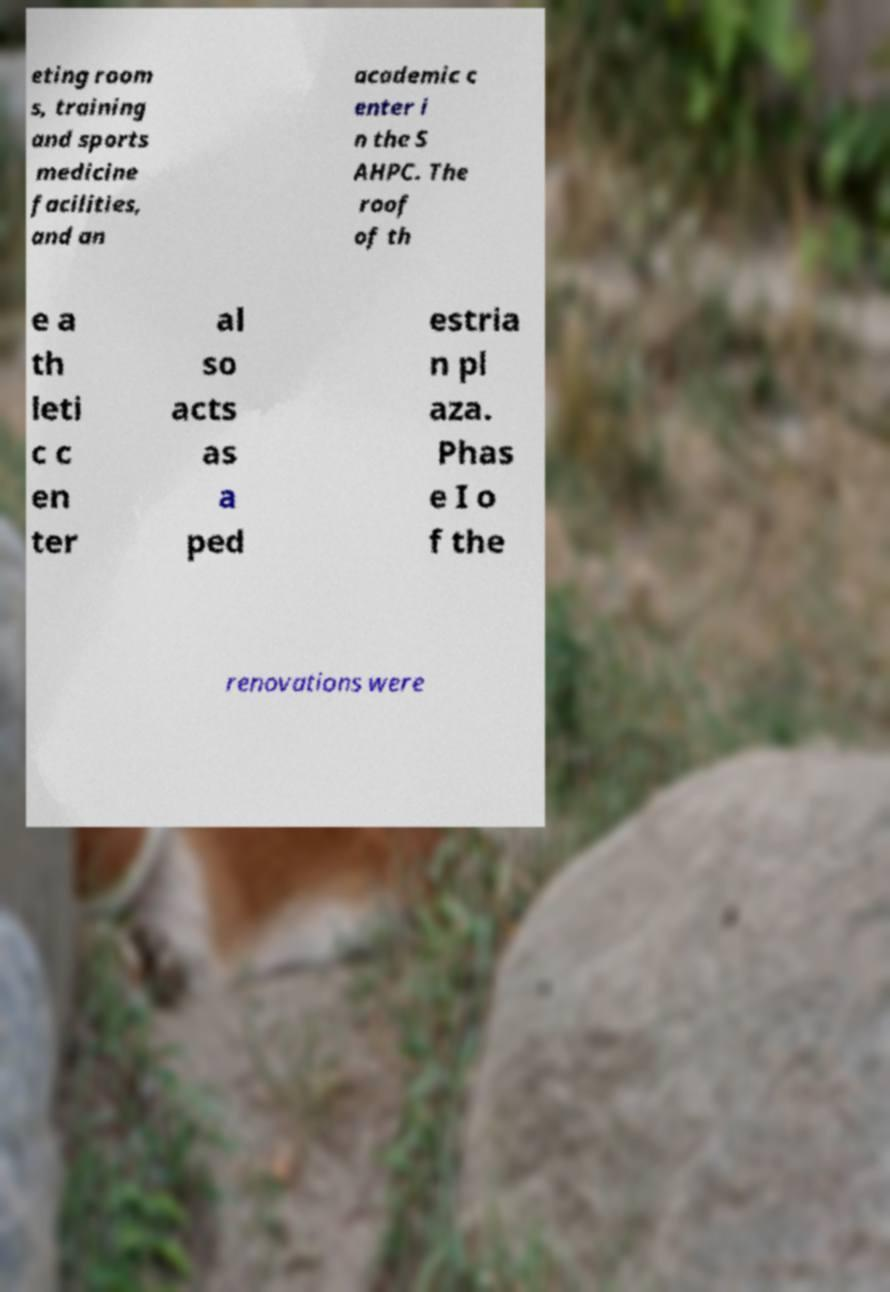For documentation purposes, I need the text within this image transcribed. Could you provide that? eting room s, training and sports medicine facilities, and an academic c enter i n the S AHPC. The roof of th e a th leti c c en ter al so acts as a ped estria n pl aza. Phas e I o f the renovations were 